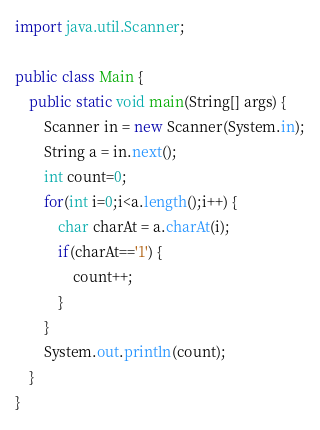Convert code to text. <code><loc_0><loc_0><loc_500><loc_500><_Java_>
import java.util.Scanner;

public class Main {
	public static void main(String[] args) {
		Scanner in = new Scanner(System.in);
		String a = in.next();
		int count=0;
		for(int i=0;i<a.length();i++) {
			char charAt = a.charAt(i);
			if(charAt=='1') {
				count++;
			}
		}
		System.out.println(count);
	}
}</code> 